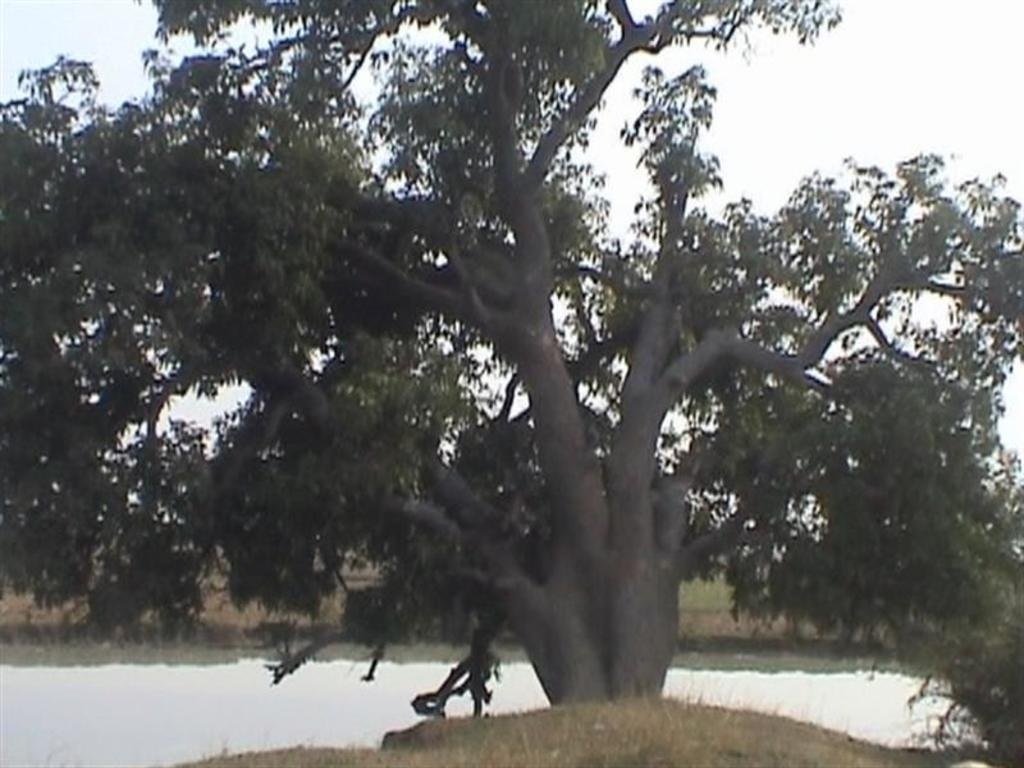What natural element is present in the image? There is a tree in the image. What can be seen in the background of the image? Water, land, and the sky are visible in the background of the image. How would you describe the sky in the image? The sky is clear and visible in the background of the image. Can you tell me what statement the girl is making in the image? There is no girl present in the image, so it is not possible to determine what statement she might be making. 